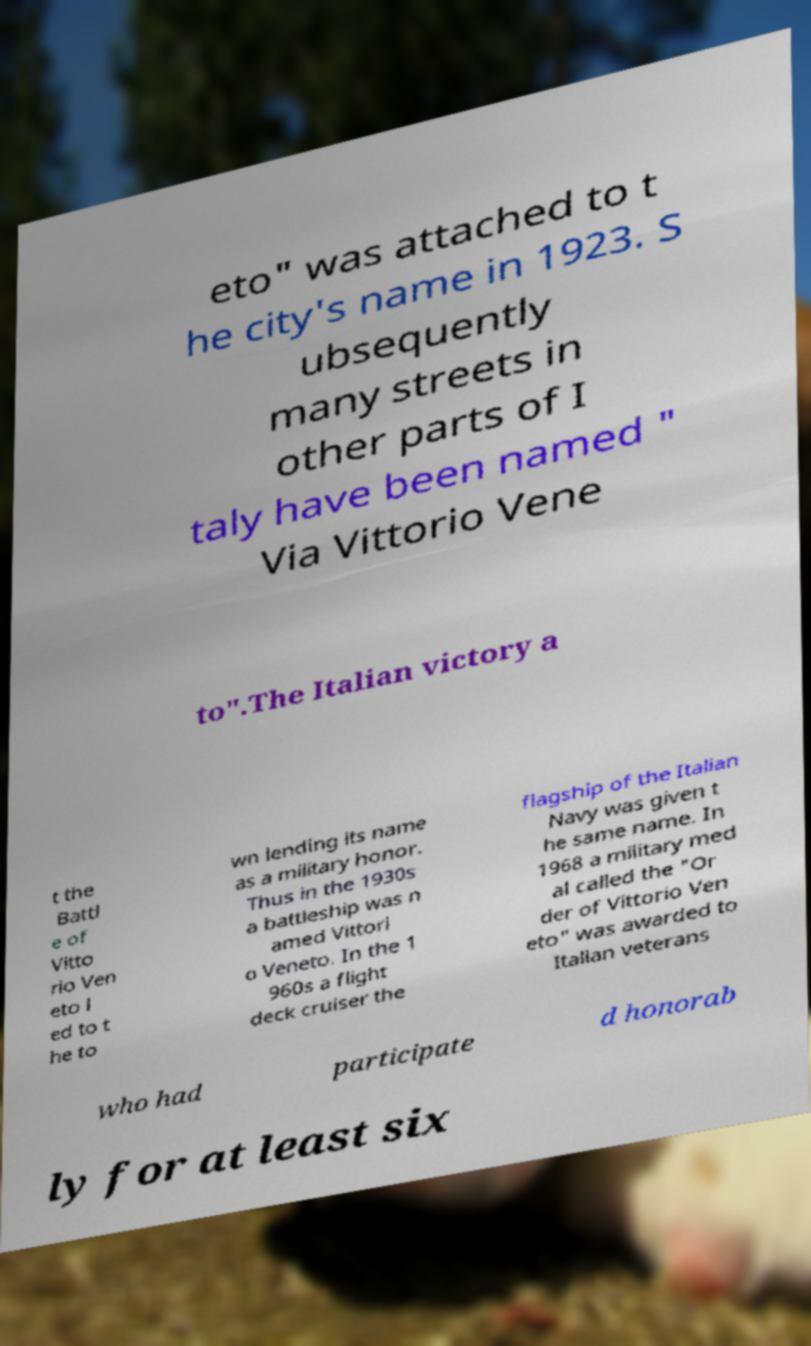For documentation purposes, I need the text within this image transcribed. Could you provide that? eto" was attached to t he city's name in 1923. S ubsequently many streets in other parts of I taly have been named " Via Vittorio Vene to".The Italian victory a t the Battl e of Vitto rio Ven eto l ed to t he to wn lending its name as a military honor. Thus in the 1930s a battleship was n amed Vittori o Veneto. In the 1 960s a flight deck cruiser the flagship of the Italian Navy was given t he same name. In 1968 a military med al called the "Or der of Vittorio Ven eto" was awarded to Italian veterans who had participate d honorab ly for at least six 